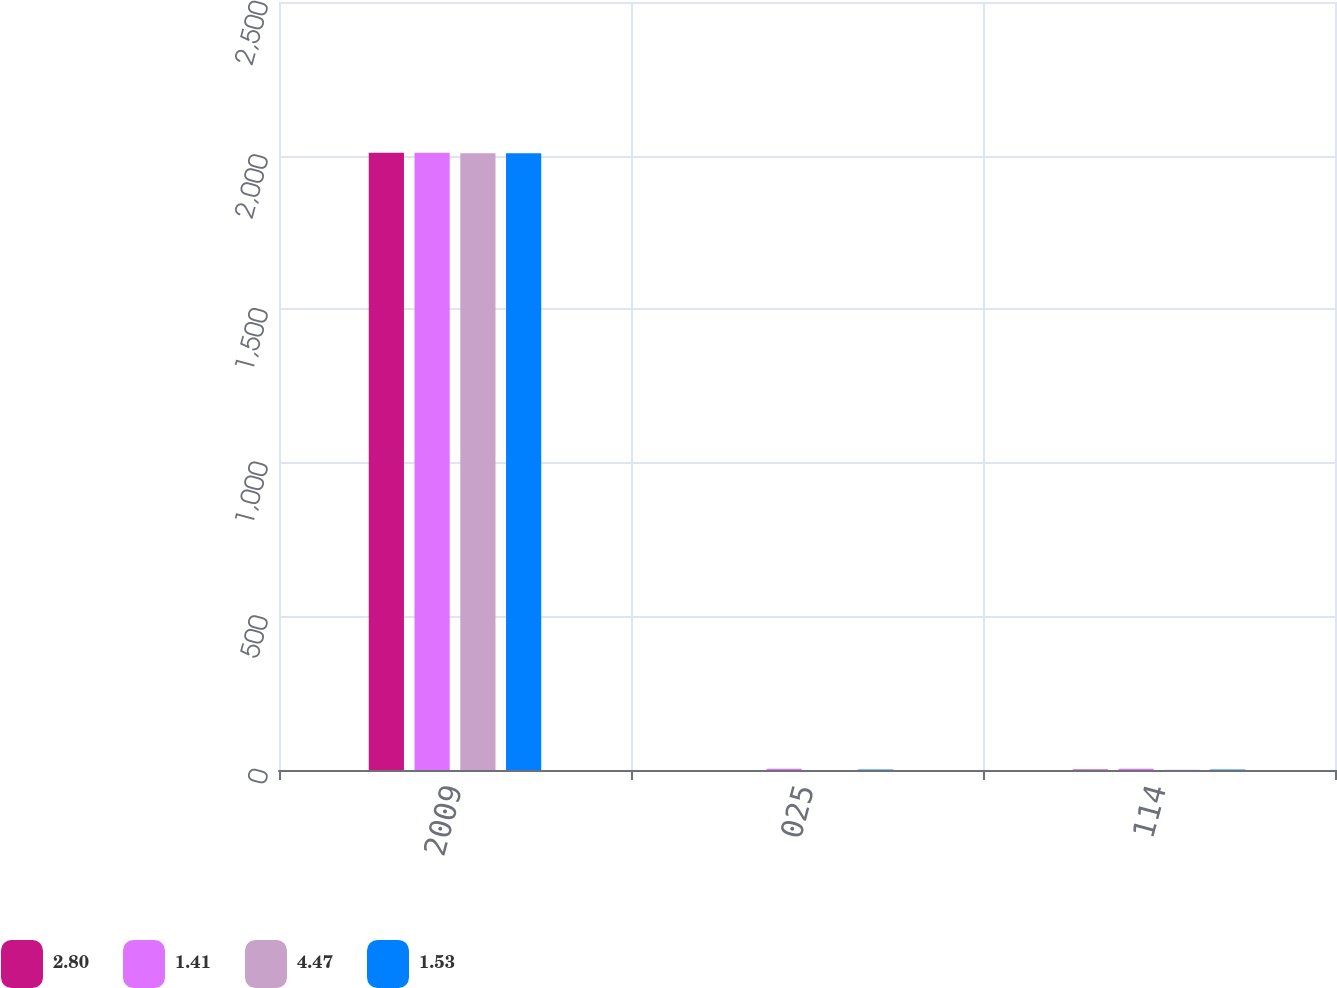<chart> <loc_0><loc_0><loc_500><loc_500><stacked_bar_chart><ecel><fcel>2009<fcel>025<fcel>114<nl><fcel>2.8<fcel>2009<fcel>0.25<fcel>1.53<nl><fcel>1.41<fcel>2009<fcel>3.97<fcel>4.47<nl><fcel>4.47<fcel>2008<fcel>0.25<fcel>0.75<nl><fcel>1.53<fcel>2008<fcel>1.43<fcel>1.41<nl></chart> 